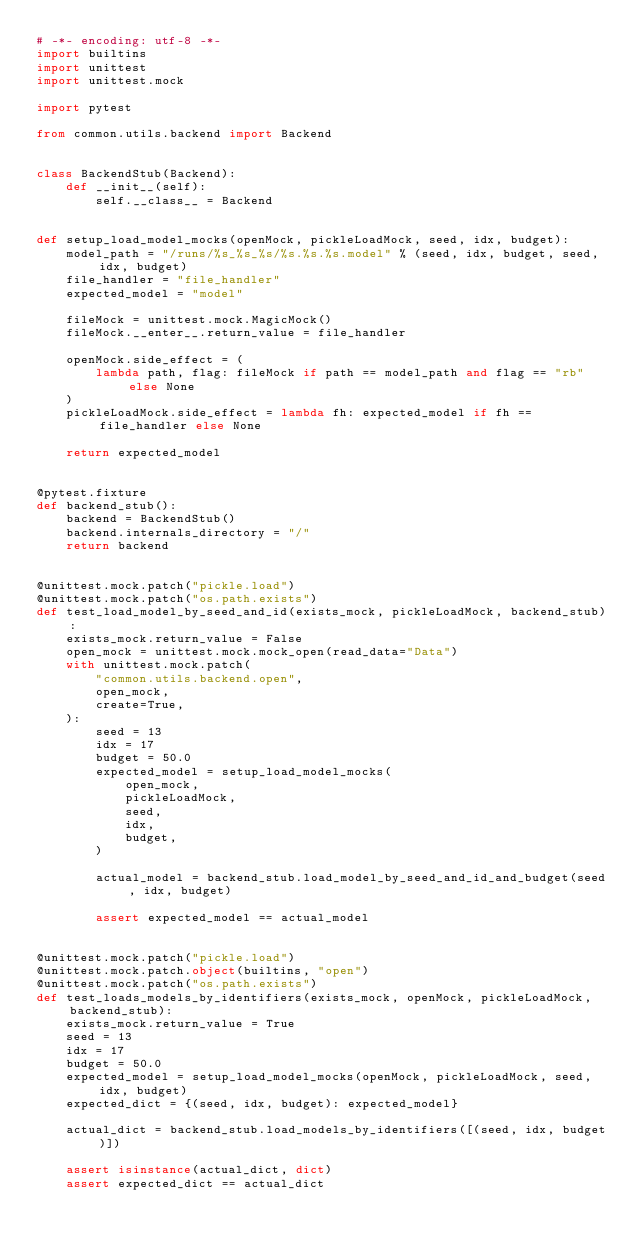Convert code to text. <code><loc_0><loc_0><loc_500><loc_500><_Python_># -*- encoding: utf-8 -*-
import builtins
import unittest
import unittest.mock

import pytest

from common.utils.backend import Backend


class BackendStub(Backend):
    def __init__(self):
        self.__class__ = Backend


def setup_load_model_mocks(openMock, pickleLoadMock, seed, idx, budget):
    model_path = "/runs/%s_%s_%s/%s.%s.%s.model" % (seed, idx, budget, seed, idx, budget)
    file_handler = "file_handler"
    expected_model = "model"

    fileMock = unittest.mock.MagicMock()
    fileMock.__enter__.return_value = file_handler

    openMock.side_effect = (
        lambda path, flag: fileMock if path == model_path and flag == "rb" else None
    )
    pickleLoadMock.side_effect = lambda fh: expected_model if fh == file_handler else None

    return expected_model


@pytest.fixture
def backend_stub():
    backend = BackendStub()
    backend.internals_directory = "/"
    return backend


@unittest.mock.patch("pickle.load")
@unittest.mock.patch("os.path.exists")
def test_load_model_by_seed_and_id(exists_mock, pickleLoadMock, backend_stub):
    exists_mock.return_value = False
    open_mock = unittest.mock.mock_open(read_data="Data")
    with unittest.mock.patch(
        "common.utils.backend.open",
        open_mock,
        create=True,
    ):
        seed = 13
        idx = 17
        budget = 50.0
        expected_model = setup_load_model_mocks(
            open_mock,
            pickleLoadMock,
            seed,
            idx,
            budget,
        )

        actual_model = backend_stub.load_model_by_seed_and_id_and_budget(seed, idx, budget)

        assert expected_model == actual_model


@unittest.mock.patch("pickle.load")
@unittest.mock.patch.object(builtins, "open")
@unittest.mock.patch("os.path.exists")
def test_loads_models_by_identifiers(exists_mock, openMock, pickleLoadMock, backend_stub):
    exists_mock.return_value = True
    seed = 13
    idx = 17
    budget = 50.0
    expected_model = setup_load_model_mocks(openMock, pickleLoadMock, seed, idx, budget)
    expected_dict = {(seed, idx, budget): expected_model}

    actual_dict = backend_stub.load_models_by_identifiers([(seed, idx, budget)])

    assert isinstance(actual_dict, dict)
    assert expected_dict == actual_dict
</code> 